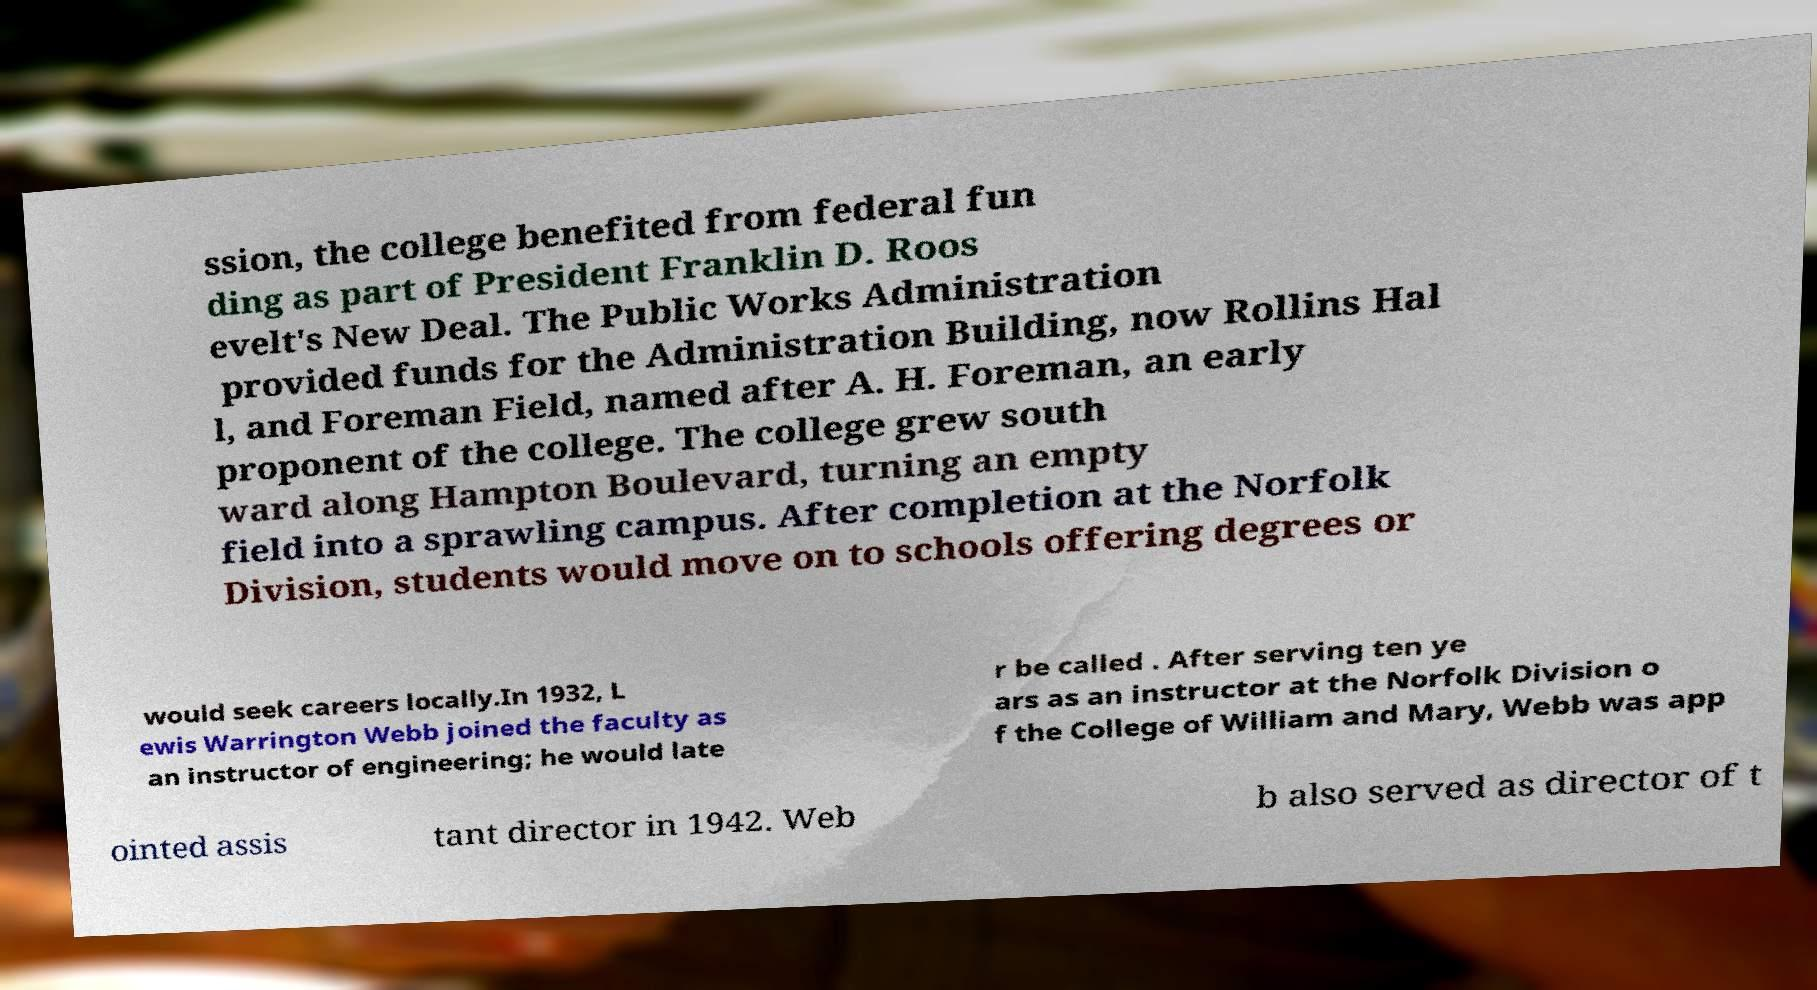There's text embedded in this image that I need extracted. Can you transcribe it verbatim? ssion, the college benefited from federal fun ding as part of President Franklin D. Roos evelt's New Deal. The Public Works Administration provided funds for the Administration Building, now Rollins Hal l, and Foreman Field, named after A. H. Foreman, an early proponent of the college. The college grew south ward along Hampton Boulevard, turning an empty field into a sprawling campus. After completion at the Norfolk Division, students would move on to schools offering degrees or would seek careers locally.In 1932, L ewis Warrington Webb joined the faculty as an instructor of engineering; he would late r be called . After serving ten ye ars as an instructor at the Norfolk Division o f the College of William and Mary, Webb was app ointed assis tant director in 1942. Web b also served as director of t 